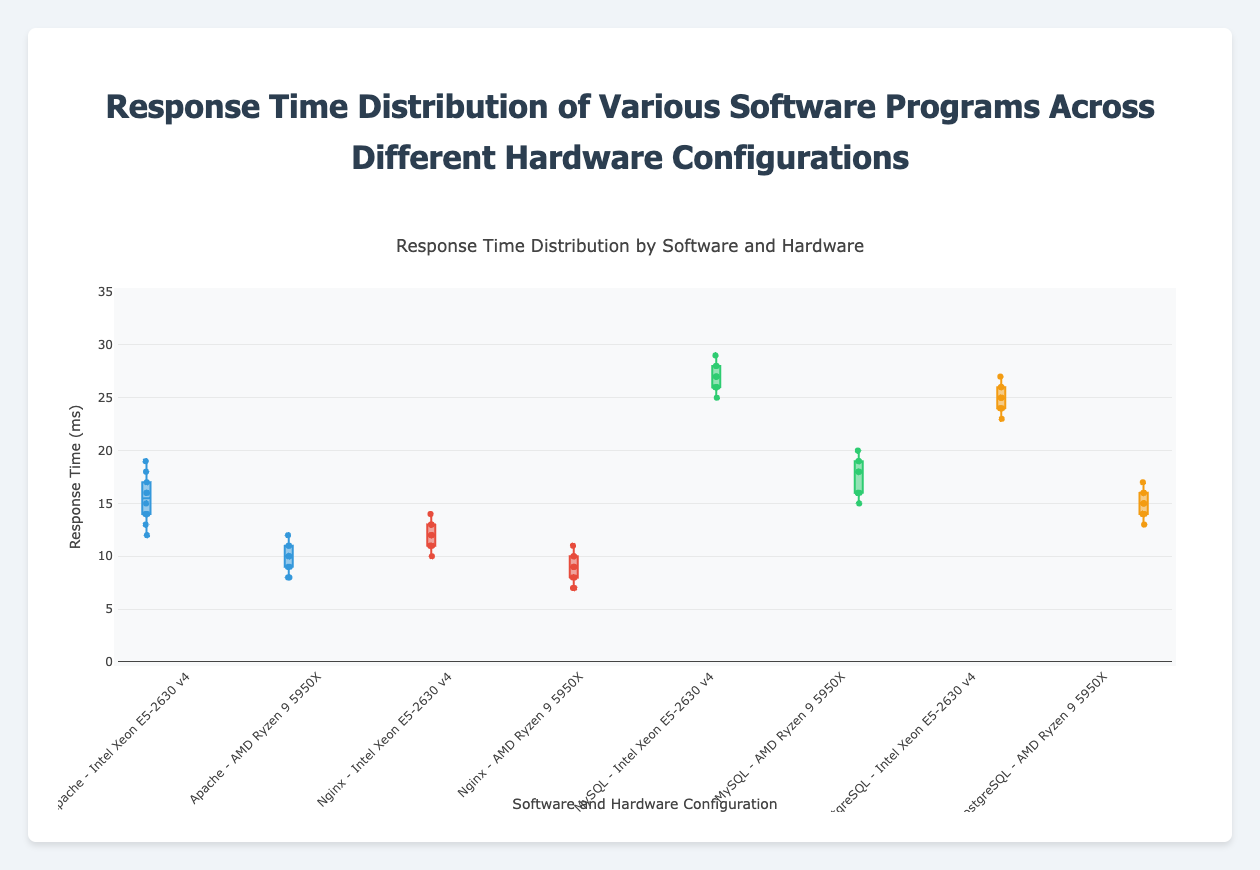What's the average response time for Apache on the Intel Xeon configuration? Sum the response times for Apache on Intel Xeon (12 + 15 + 13 + 17 + 16 + 14 + 18 + 19 + 14 + 16) = 154, then divide by the number of data points (10), so the average is 154/10 = 15.4 ms
Answer: 15.4 ms Which software has a lower average response time on AMD Ryzen, Apache or Nginx? Calculate the average response time for both software on AMD Ryzen. Apache: (8 + 10 + 9 + 11 + 10 + 9 + 11 + 12 + 8 + 10) / 10 = 9.8 ms. Nginx: (7 + 9 + 8 + 10 + 9 + 8 + 10 + 11 + 7 + 9) / 10 = 8.8 ms. Nginx has a lower average response time.
Answer: Nginx Is the median response time for MySQL on Intel Xeon greater than PostgreSQL on AMD Ryzen? Find the medians. For MySQL on Intel Xeon: sorted times [25, 26, 26, 26, 27, 27, 27, 28, 28, 29], median=27 ms. For PostgreSQL on AMD Ryzen: sorted times [13, 14, 14, 14, 15, 15, 15, 16, 16, 17], median=15 ms. Yes, the median for MySQL is greater.
Answer: Yes Which software shows the highest response time variability on Intel Xeon, Apache or PostgreSQL? Compare the range (max - min) of response times. Apache: (19 - 12) = 7 ms. PostgreSQL: (27 - 23) = 4 ms. Apache has higher variability.
Answer: Apache What color represents the response time distribution for Nginx on AMD Ryzen? Identify the color in the plot legend or by visual inspection in the figure. It is green.
Answer: Green Are the median response times for Apache on Intel Xeon and AMD Ryzen configurations equal? Find the medians: For Intel Xeon: sorted times [12, 13, 14, 14, 15, 16, 16, 17, 18, 19], median between 15 and 16 =15.5 ms. For AMD Ryzen: sorted times [8, 8, 9, 9, 9, 10, 10, 10, 11, 12], median between 9 and 10 = 9.5 ms. They are not equal.
Answer: No Which software has the highest median response time on AMD Ryzen? Calculate and compare the median response times. Apache: 9.5 ms, Nginx: 8.5 ms, MySQL: 17 ms, PostgreSQL: 15 ms. MySQL has the highest median response time.
Answer: MySQL What is the range of response times for PostgreSQL on Intel Xeon? Find the maximum and minimum response times: max = 27 ms, min = 23 ms; range = 27 - 23 = 4 ms.
Answer: 4 ms Is the average response time for MySQL on AMD Ryzen less than 20 ms? Calculate the average: (15 + 18 + 16 + 19 + 18 + 16 + 19 + 20 + 16 + 18) / 10 = 17.5 ms. Yes, it is less than 20 ms.
Answer: Yes Which hardware configuration overall shows better performance for the same software, Intel Xeon or AMD Ryzen? Compare the average or median response times for each software across both configurations. Consistently, AMD Ryzen shows lower response times (better performance) for each software.
Answer: AMD Ryzen 